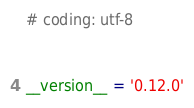<code> <loc_0><loc_0><loc_500><loc_500><_Python_># coding: utf-8


__version__ = '0.12.0'
</code> 